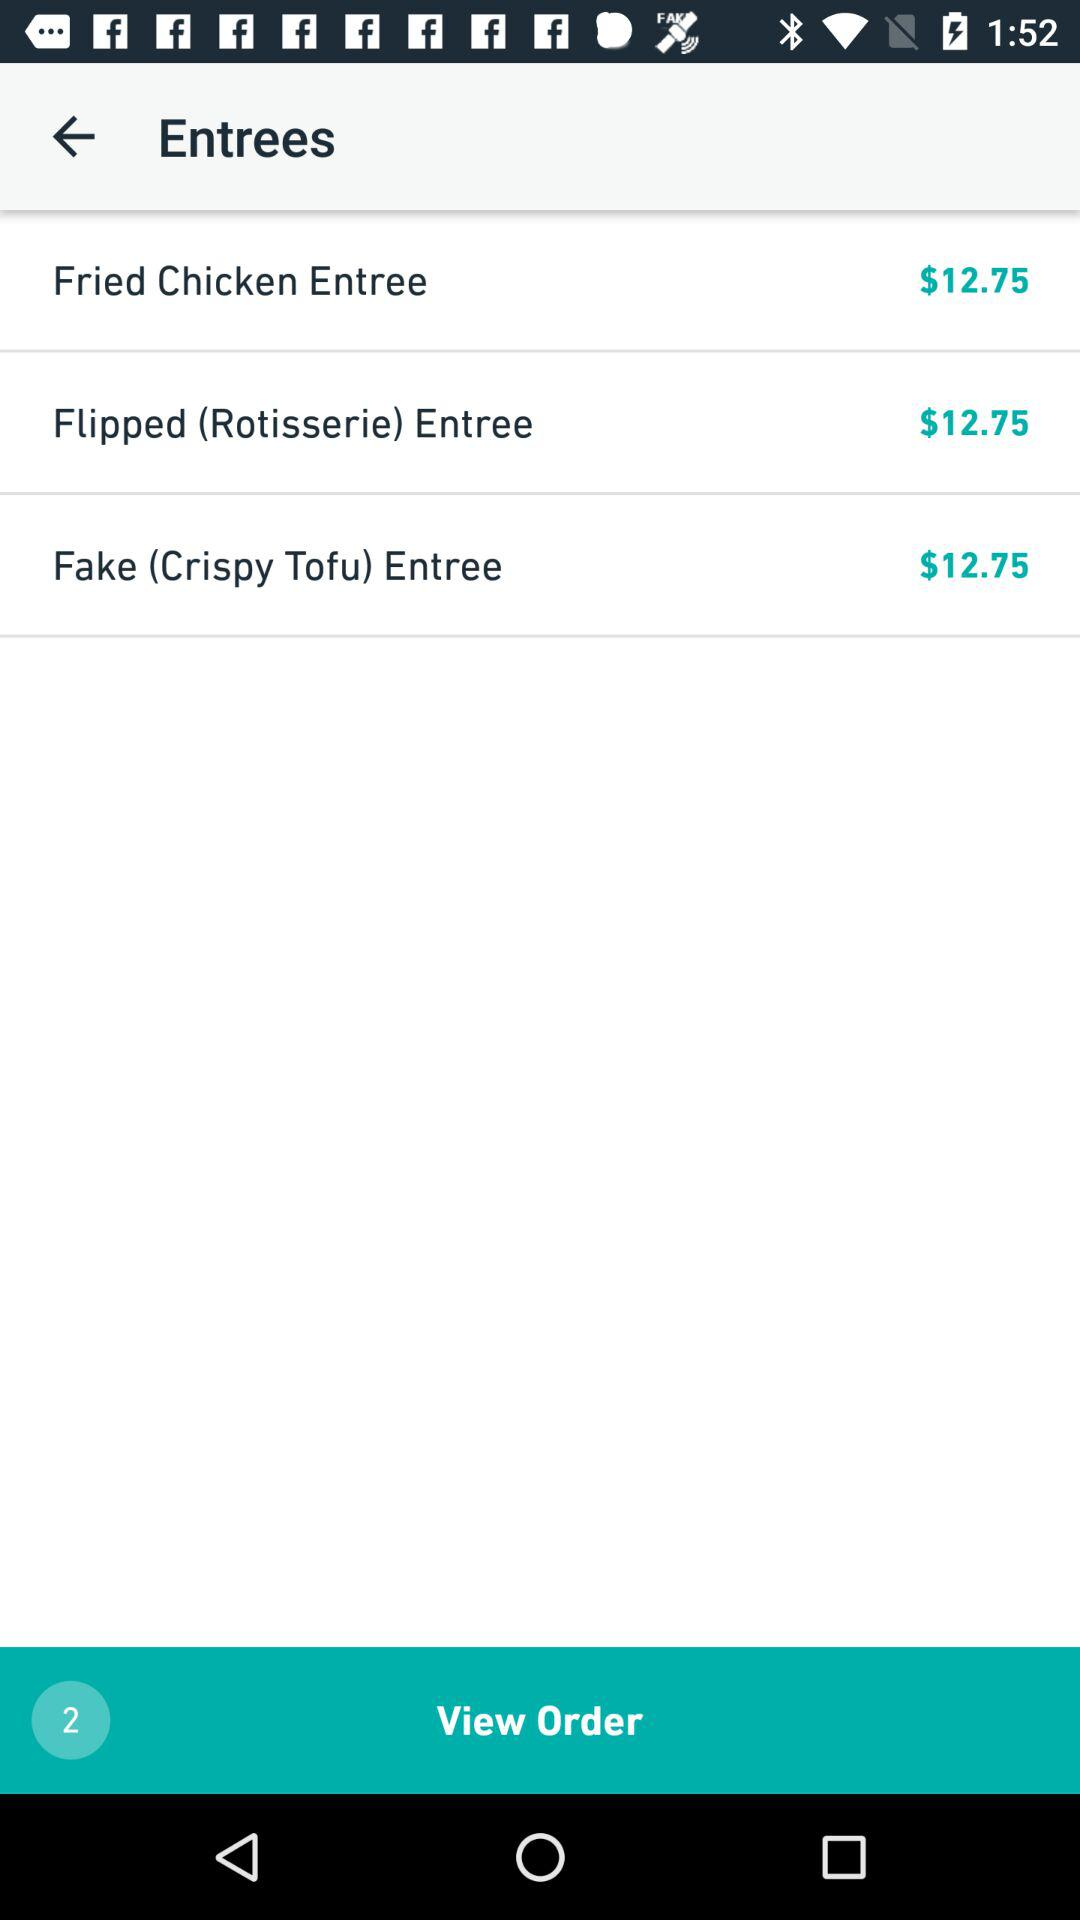What is the total price of the entrees?
Answer the question using a single word or phrase. $38.25 